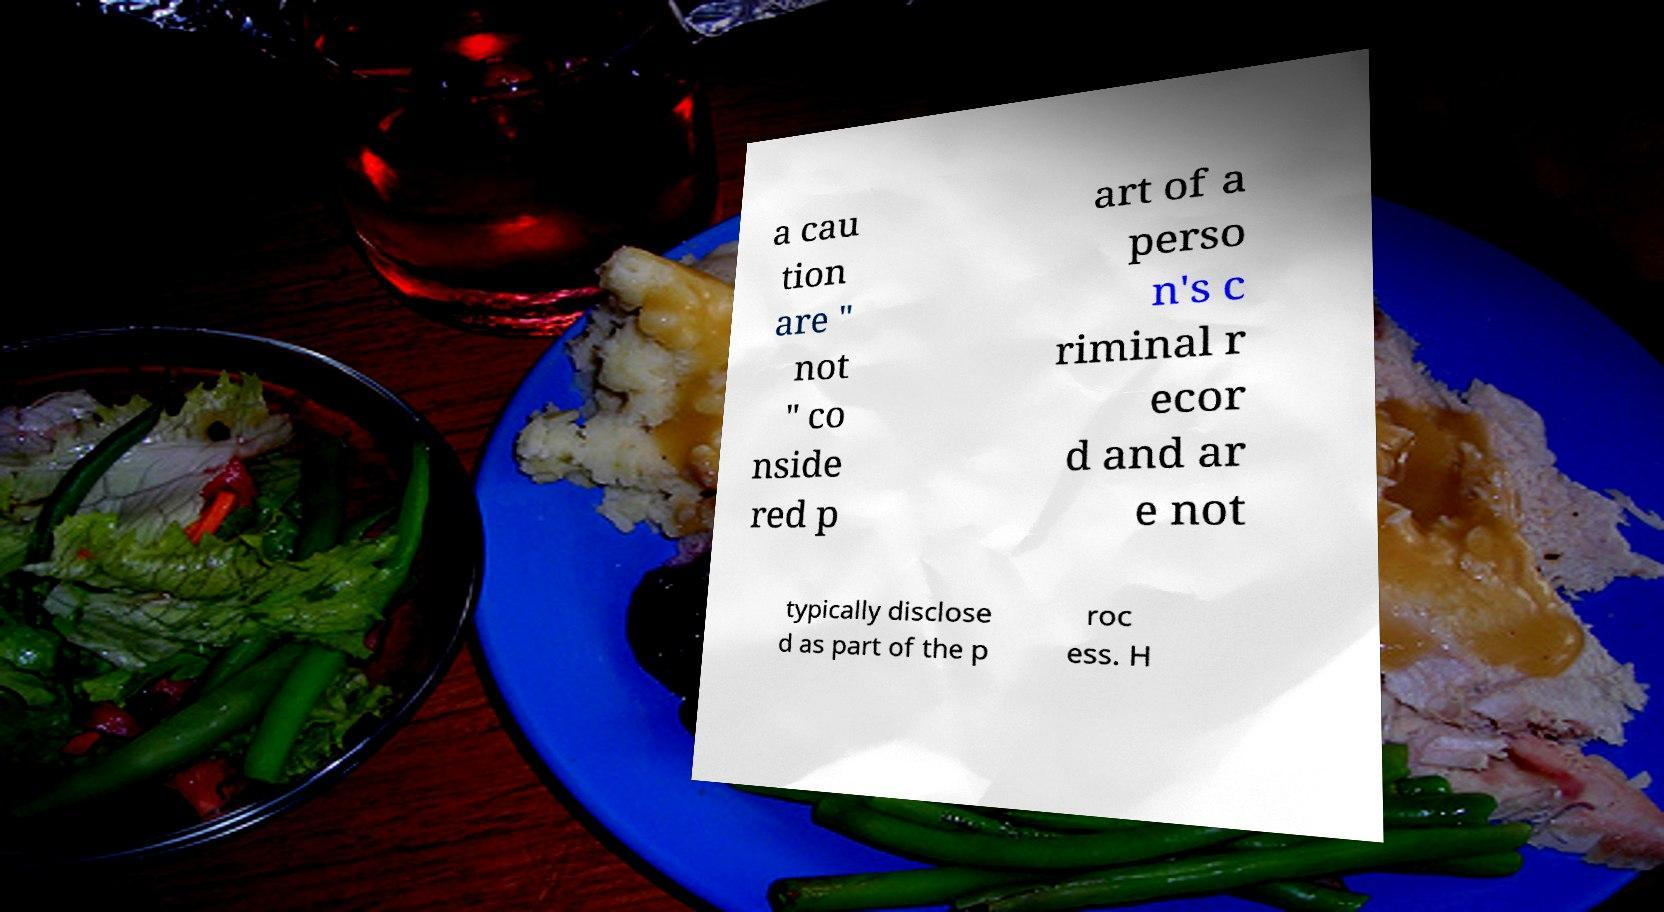Could you extract and type out the text from this image? a cau tion are " not " co nside red p art of a perso n's c riminal r ecor d and ar e not typically disclose d as part of the p roc ess. H 